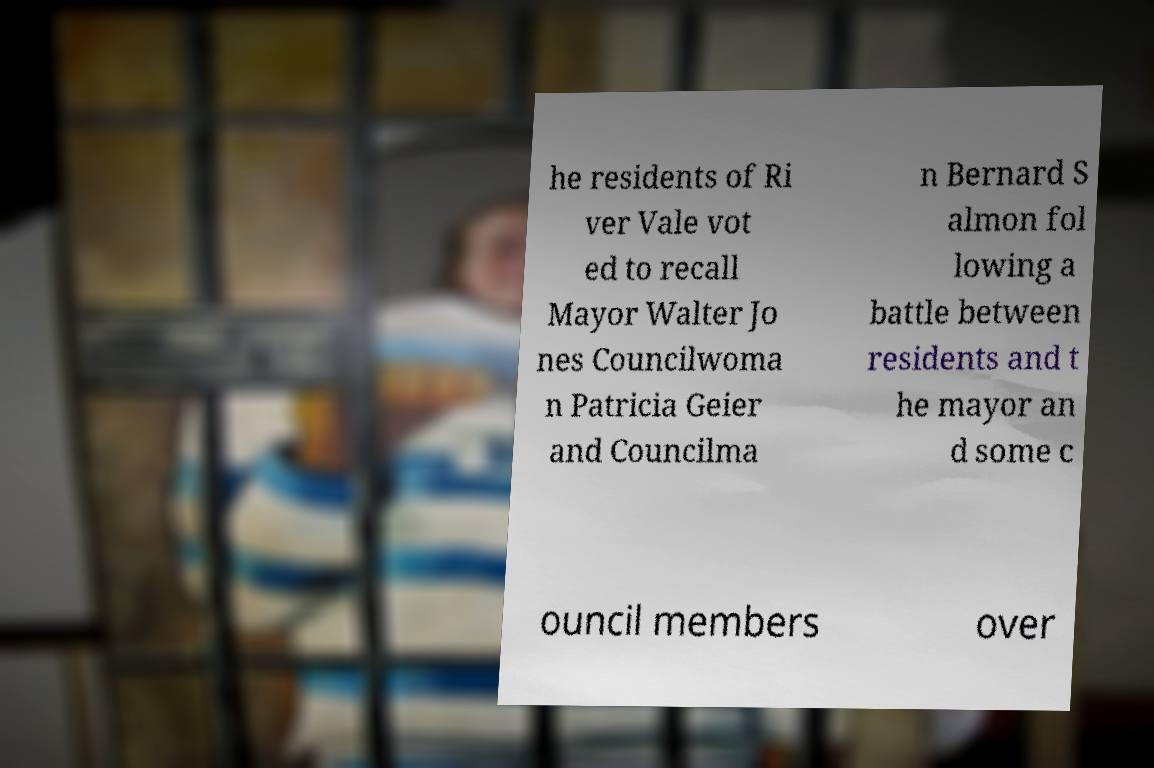Could you assist in decoding the text presented in this image and type it out clearly? he residents of Ri ver Vale vot ed to recall Mayor Walter Jo nes Councilwoma n Patricia Geier and Councilma n Bernard S almon fol lowing a battle between residents and t he mayor an d some c ouncil members over 